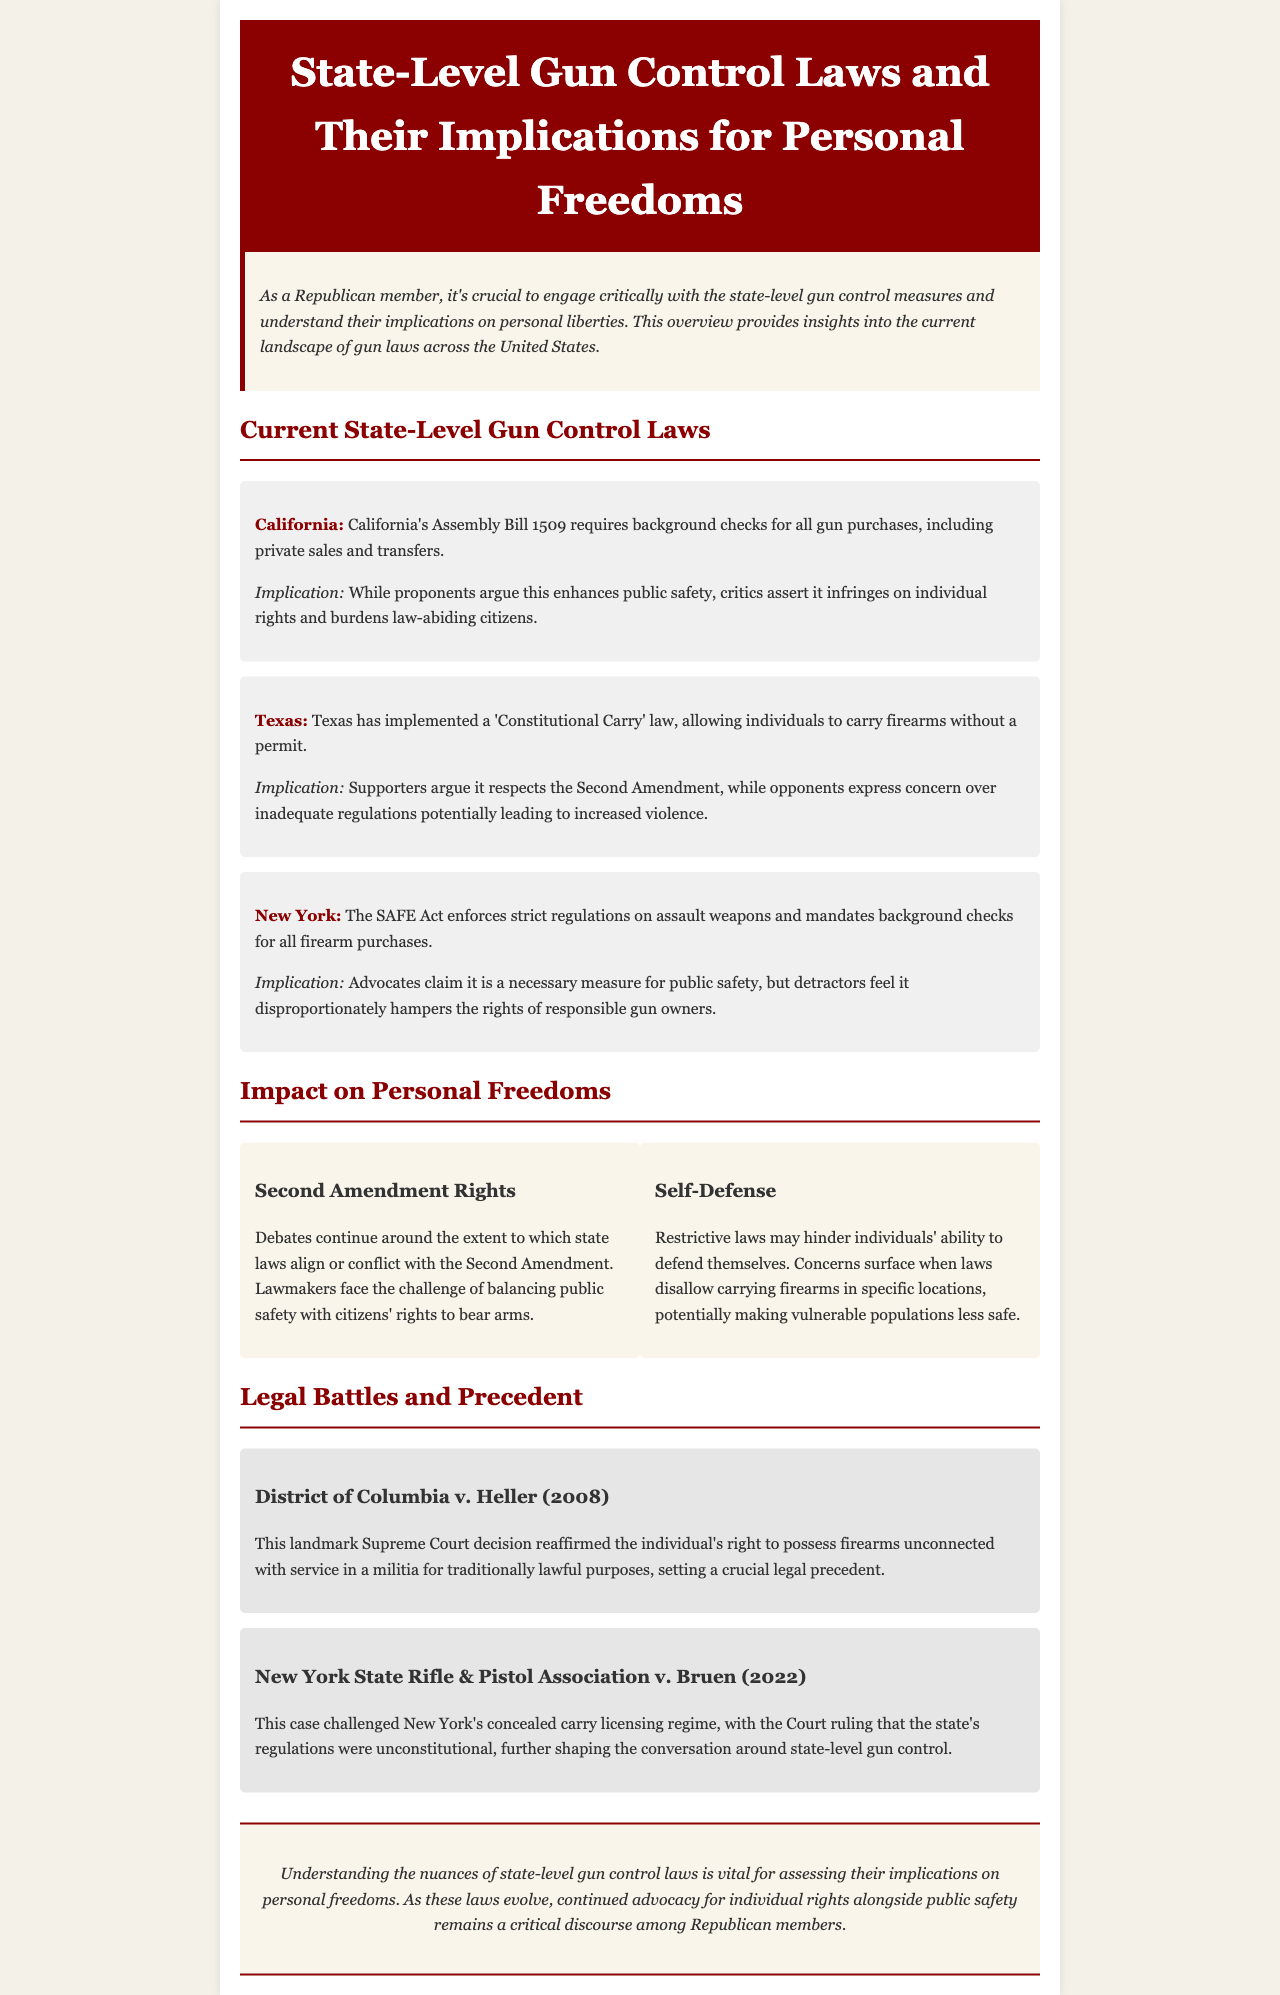What is California's Assembly Bill 1509? California’s Assembly Bill 1509 requires background checks for all gun purchases, including private sales and transfers.
Answer: Requires background checks What law does Texas implement regarding firearm carrying? Texas has implemented a 'Constitutional Carry' law, allowing individuals to carry firearms without a permit.
Answer: 'Constitutional Carry' law What does the SAFE Act regulate in New York? The SAFE Act enforces strict regulations on assault weapons and mandates background checks for all firearm purchases.
Answer: Assault weapons and background checks What is the significance of District of Columbia v. Heller (2008)? The case reaffirmed the individual's right to possess firearms unconnected with service in a militia for traditionally lawful purposes.
Answer: Individual's right to possess firearms What are the two key considerations in the conversation about gun control laws? The key considerations are public safety and citizens' rights to bear arms.
Answer: Public safety and citizens' rights What does the section on self-defense highlight? It highlights concerns that restrictive laws may hinder individuals' ability to defend themselves.
Answer: Hinders self-defense ability How many states' gun control laws are discussed in the newsletter? The newsletter specifically discusses the gun control laws of three states.
Answer: Three states What is the overall theme of the newsletter? The overall theme is assessing state-level gun control laws and their implications for personal freedoms.
Answer: Implications for personal freedoms 